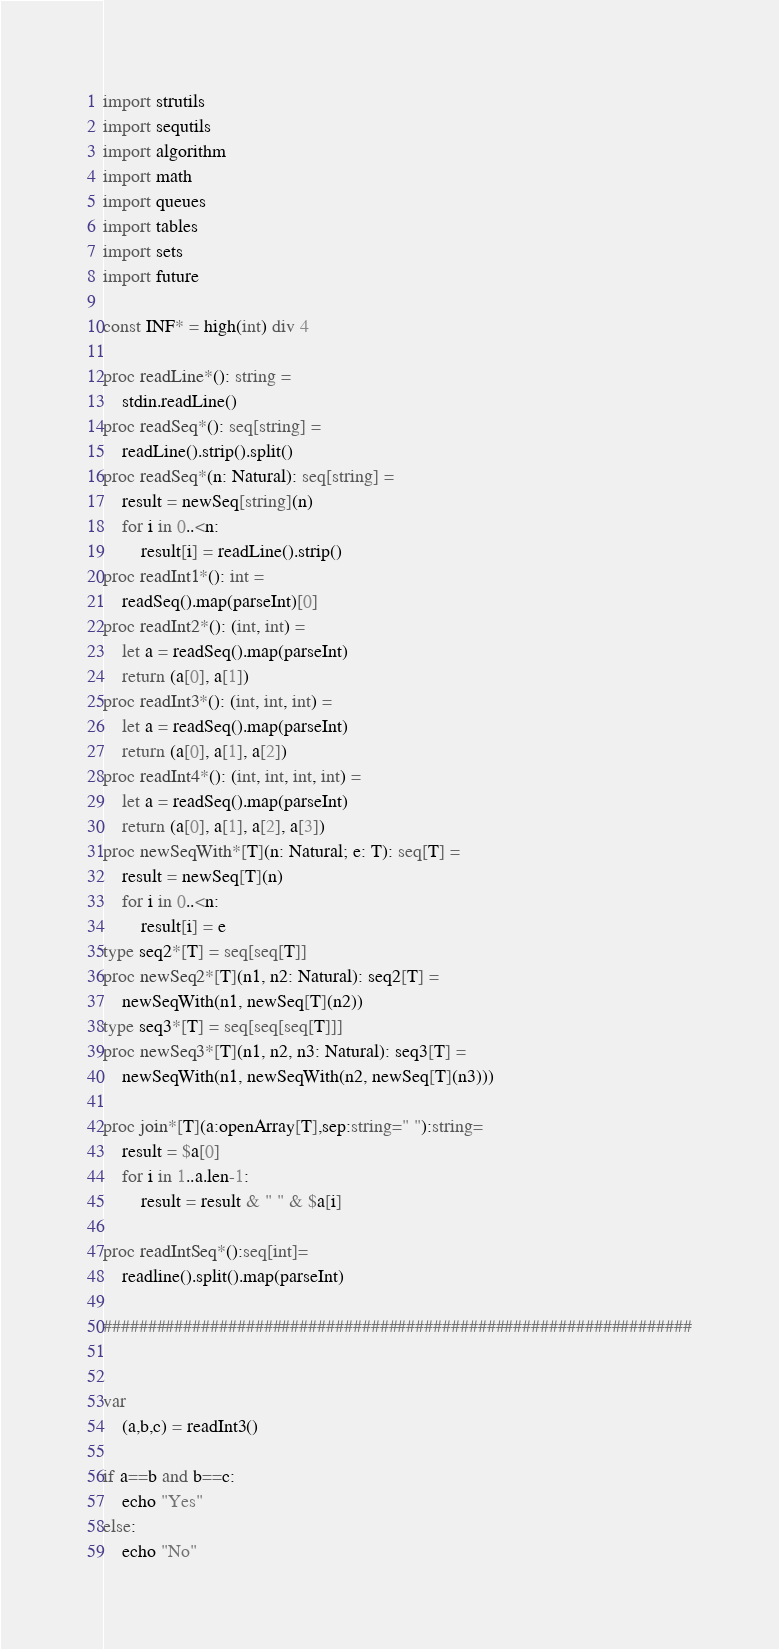Convert code to text. <code><loc_0><loc_0><loc_500><loc_500><_Nim_>import strutils
import sequtils
import algorithm
import math
import queues
import tables
import sets
import future
 
const INF* = high(int) div 4
 
proc readLine*(): string =
    stdin.readLine()
proc readSeq*(): seq[string] =
    readLine().strip().split()
proc readSeq*(n: Natural): seq[string] =
    result = newSeq[string](n)
    for i in 0..<n:
        result[i] = readLine().strip()
proc readInt1*(): int =
    readSeq().map(parseInt)[0]
proc readInt2*(): (int, int) =
    let a = readSeq().map(parseInt)
    return (a[0], a[1])
proc readInt3*(): (int, int, int) =
    let a = readSeq().map(parseInt)
    return (a[0], a[1], a[2])
proc readInt4*(): (int, int, int, int) =
    let a = readSeq().map(parseInt)
    return (a[0], a[1], a[2], a[3])
proc newSeqWith*[T](n: Natural; e: T): seq[T] =
    result = newSeq[T](n)
    for i in 0..<n:
        result[i] = e
type seq2*[T] = seq[seq[T]]
proc newSeq2*[T](n1, n2: Natural): seq2[T] =
    newSeqWith(n1, newSeq[T](n2))
type seq3*[T] = seq[seq[seq[T]]]
proc newSeq3*[T](n1, n2, n3: Natural): seq3[T] =
    newSeqWith(n1, newSeqWith(n2, newSeq[T](n3)))

proc join*[T](a:openArray[T],sep:string=" "):string=
    result = $a[0]
    for i in 1..a.len-1:
        result = result & " " & $a[i]

proc readIntSeq*():seq[int]=
    readline().split().map(parseInt)

##################################################################


var
    (a,b,c) = readInt3()

if a==b and b==c:
    echo "Yes"
else:
    echo "No"</code> 